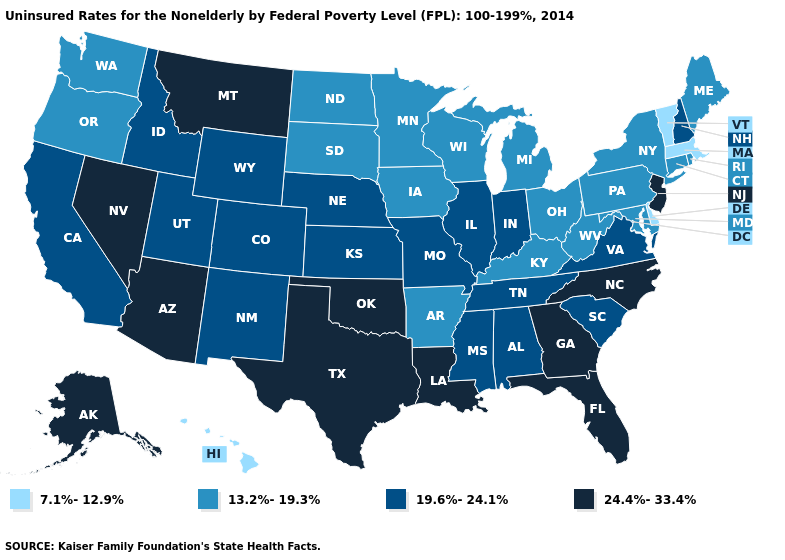Among the states that border Maryland , which have the highest value?
Keep it brief. Virginia. What is the lowest value in the USA?
Be succinct. 7.1%-12.9%. Which states have the lowest value in the USA?
Write a very short answer. Delaware, Hawaii, Massachusetts, Vermont. What is the lowest value in the Northeast?
Quick response, please. 7.1%-12.9%. Does Montana have a higher value than Indiana?
Quick response, please. Yes. Does Nevada have the highest value in the USA?
Keep it brief. Yes. Which states hav the highest value in the Northeast?
Write a very short answer. New Jersey. What is the highest value in the USA?
Write a very short answer. 24.4%-33.4%. Does Georgia have the highest value in the South?
Quick response, please. Yes. Does Vermont have the lowest value in the USA?
Concise answer only. Yes. What is the highest value in the MidWest ?
Be succinct. 19.6%-24.1%. What is the value of Maine?
Short answer required. 13.2%-19.3%. What is the value of Nebraska?
Concise answer only. 19.6%-24.1%. How many symbols are there in the legend?
Give a very brief answer. 4. Among the states that border Wisconsin , which have the highest value?
Keep it brief. Illinois. 